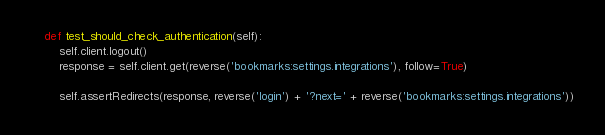<code> <loc_0><loc_0><loc_500><loc_500><_Python_>    def test_should_check_authentication(self):
        self.client.logout()
        response = self.client.get(reverse('bookmarks:settings.integrations'), follow=True)

        self.assertRedirects(response, reverse('login') + '?next=' + reverse('bookmarks:settings.integrations'))
</code> 